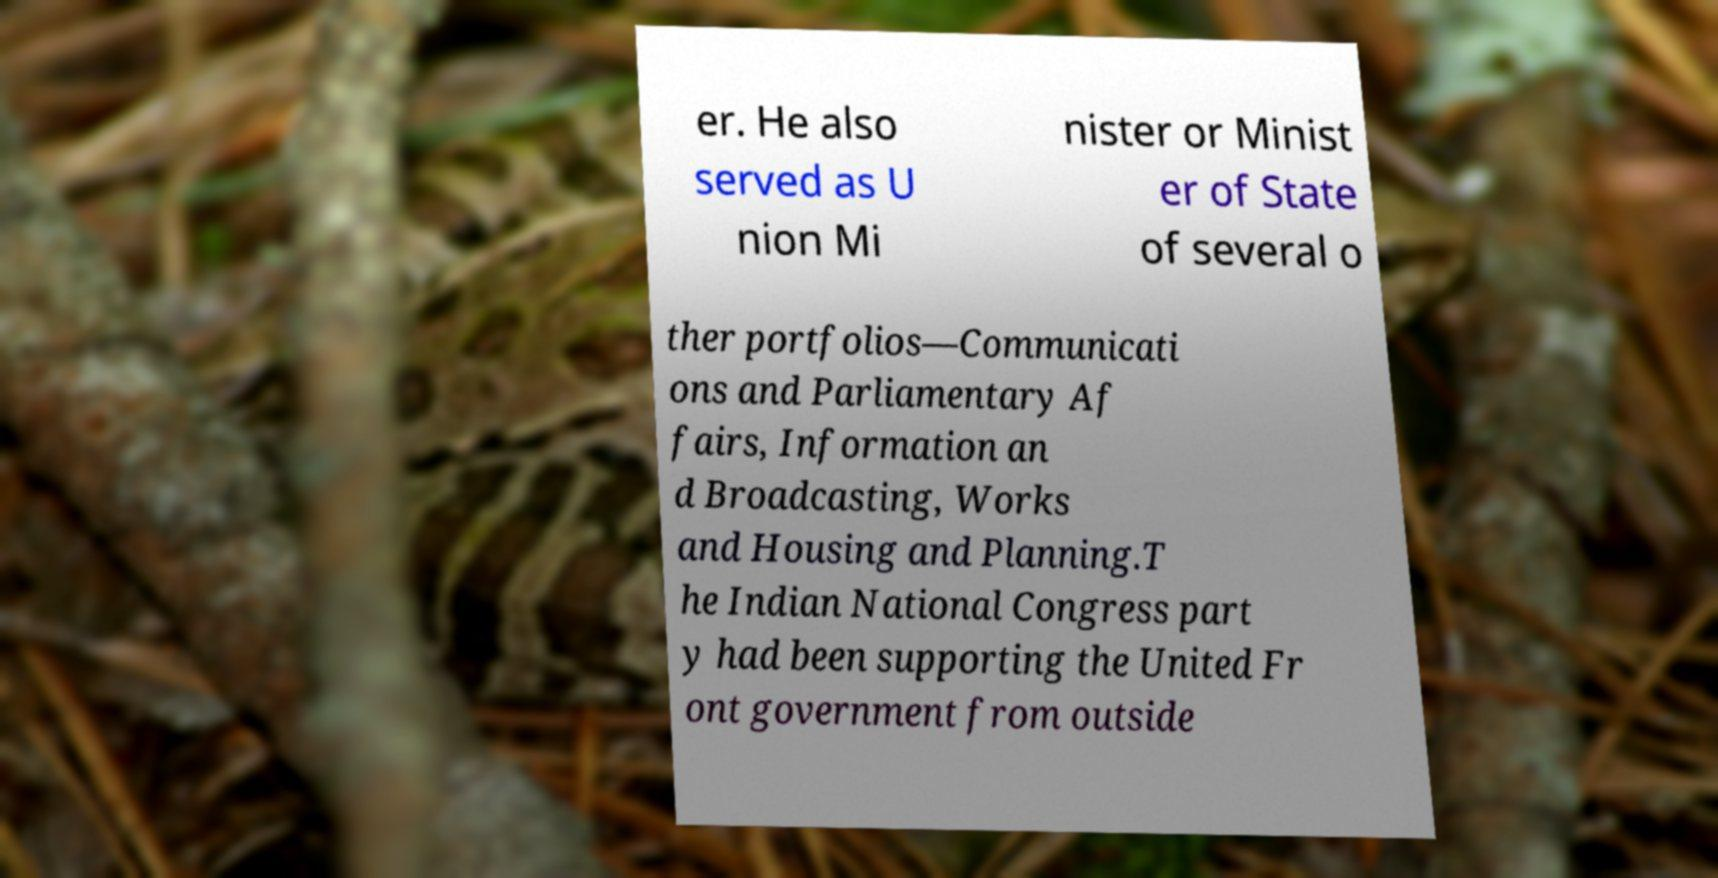Please identify and transcribe the text found in this image. er. He also served as U nion Mi nister or Minist er of State of several o ther portfolios—Communicati ons and Parliamentary Af fairs, Information an d Broadcasting, Works and Housing and Planning.T he Indian National Congress part y had been supporting the United Fr ont government from outside 